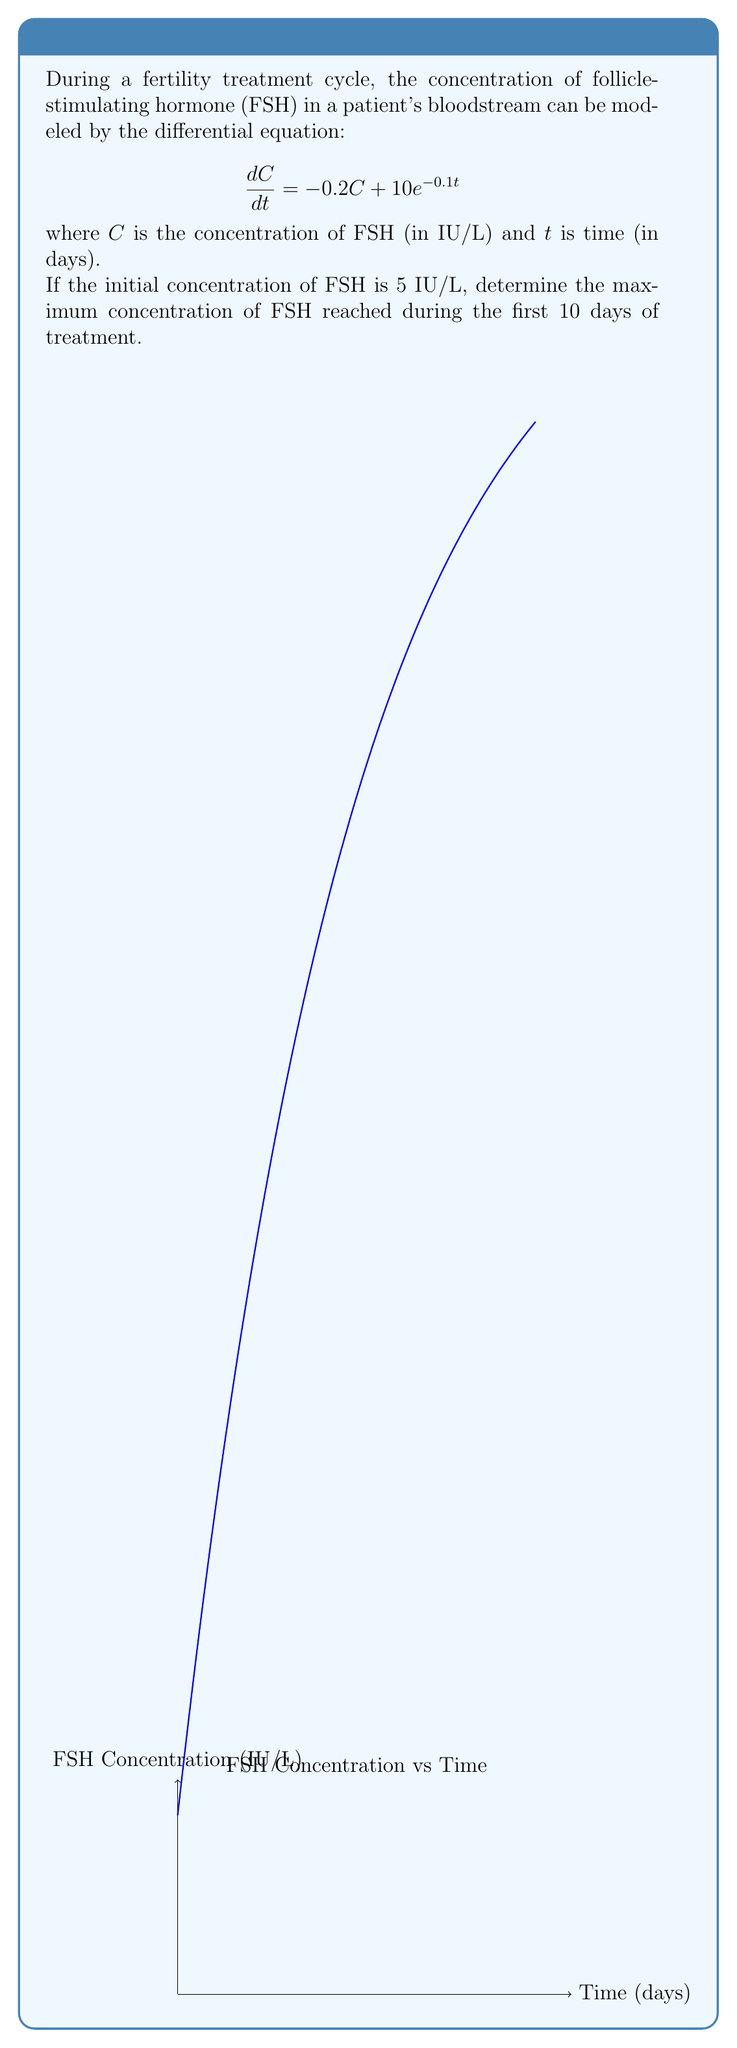Provide a solution to this math problem. To solve this problem, we'll follow these steps:

1) First, we need to solve the differential equation. This is a first-order linear differential equation.

2) The general solution to this equation is:
   $$C(t) = Ae^{-0.2t} + 50 - 45e^{-0.1t}$$
   where $A$ is a constant determined by the initial condition.

3) Using the initial condition $C(0) = 5$, we can find $A$:
   $$5 = A + 50 - 45$$
   $$A = 0$$

4) Therefore, the particular solution is:
   $$C(t) = 50 - 45e^{-0.1t}$$

5) To find the maximum concentration, we need to find where $\frac{dC}{dt} = 0$:
   $$\frac{dC}{dt} = 4.5e^{-0.1t}$$

6) This is always positive for positive $t$, meaning $C(t)$ is always increasing in the given interval.

7) Therefore, the maximum concentration in the first 10 days will occur at $t = 10$.

8) Calculating $C(10)$:
   $$C(10) = 50 - 45e^{-0.1(10)} \approx 21.85 \text{ IU/L}$$
Answer: 21.85 IU/L 